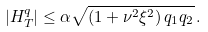<formula> <loc_0><loc_0><loc_500><loc_500>| H _ { T } ^ { q } | \leq \alpha \sqrt { \left ( 1 + \nu ^ { 2 } \xi ^ { 2 } \right ) q _ { 1 } q _ { 2 } } \, .</formula> 